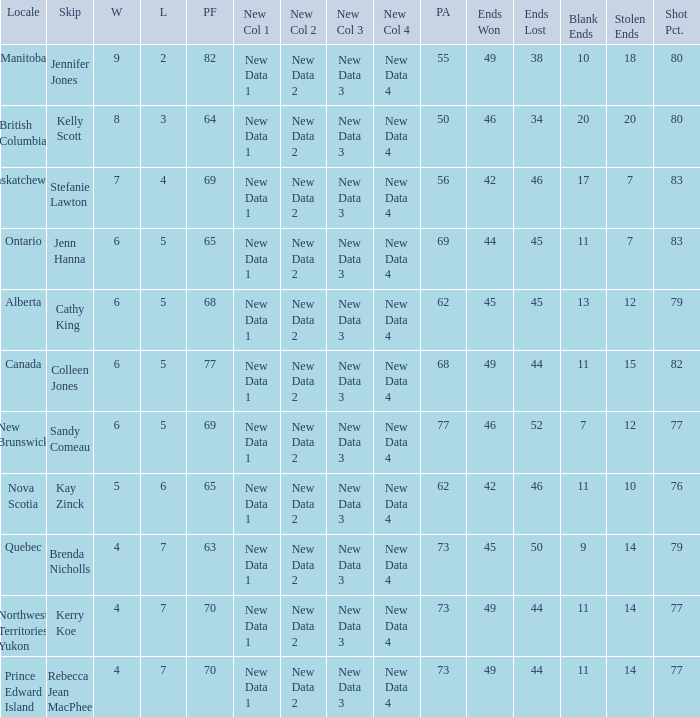What is the PA when the PF is 77? 68.0. 